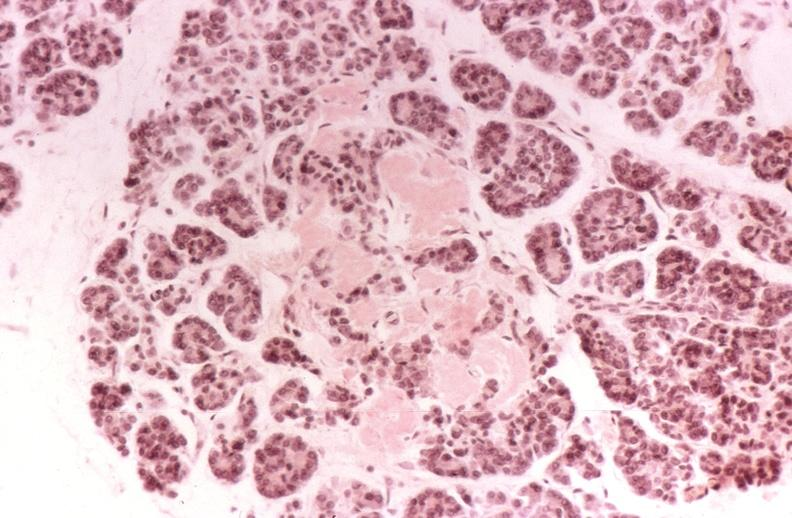what does this image show?
Answer the question using a single word or phrase. Kidney 